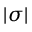<formula> <loc_0><loc_0><loc_500><loc_500>| \sigma |</formula> 